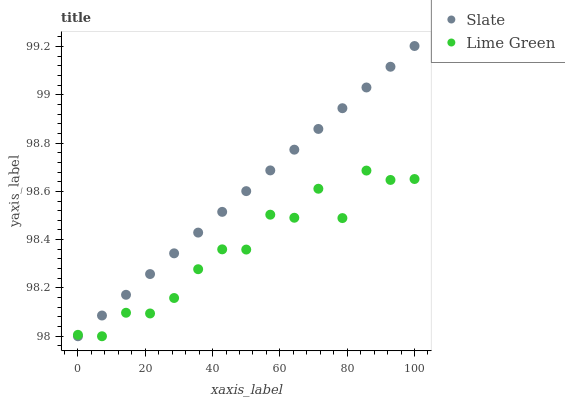Does Lime Green have the minimum area under the curve?
Answer yes or no. Yes. Does Slate have the maximum area under the curve?
Answer yes or no. Yes. Does Lime Green have the maximum area under the curve?
Answer yes or no. No. Is Slate the smoothest?
Answer yes or no. Yes. Is Lime Green the roughest?
Answer yes or no. Yes. Is Lime Green the smoothest?
Answer yes or no. No. Does Slate have the lowest value?
Answer yes or no. Yes. Does Slate have the highest value?
Answer yes or no. Yes. Does Lime Green have the highest value?
Answer yes or no. No. Does Lime Green intersect Slate?
Answer yes or no. Yes. Is Lime Green less than Slate?
Answer yes or no. No. Is Lime Green greater than Slate?
Answer yes or no. No. 